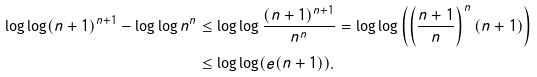Convert formula to latex. <formula><loc_0><loc_0><loc_500><loc_500>\log \log ( n + 1 ) ^ { n + 1 } - \log \log n ^ { n } & \leq \log \log \frac { ( n + 1 ) ^ { n + 1 } } { n ^ { n } } = \log \log \left ( \left ( \frac { n + 1 } { n } \right ) ^ { n } ( n + 1 ) \right ) \\ & \leq \log \log ( e ( n + 1 ) ) .</formula> 